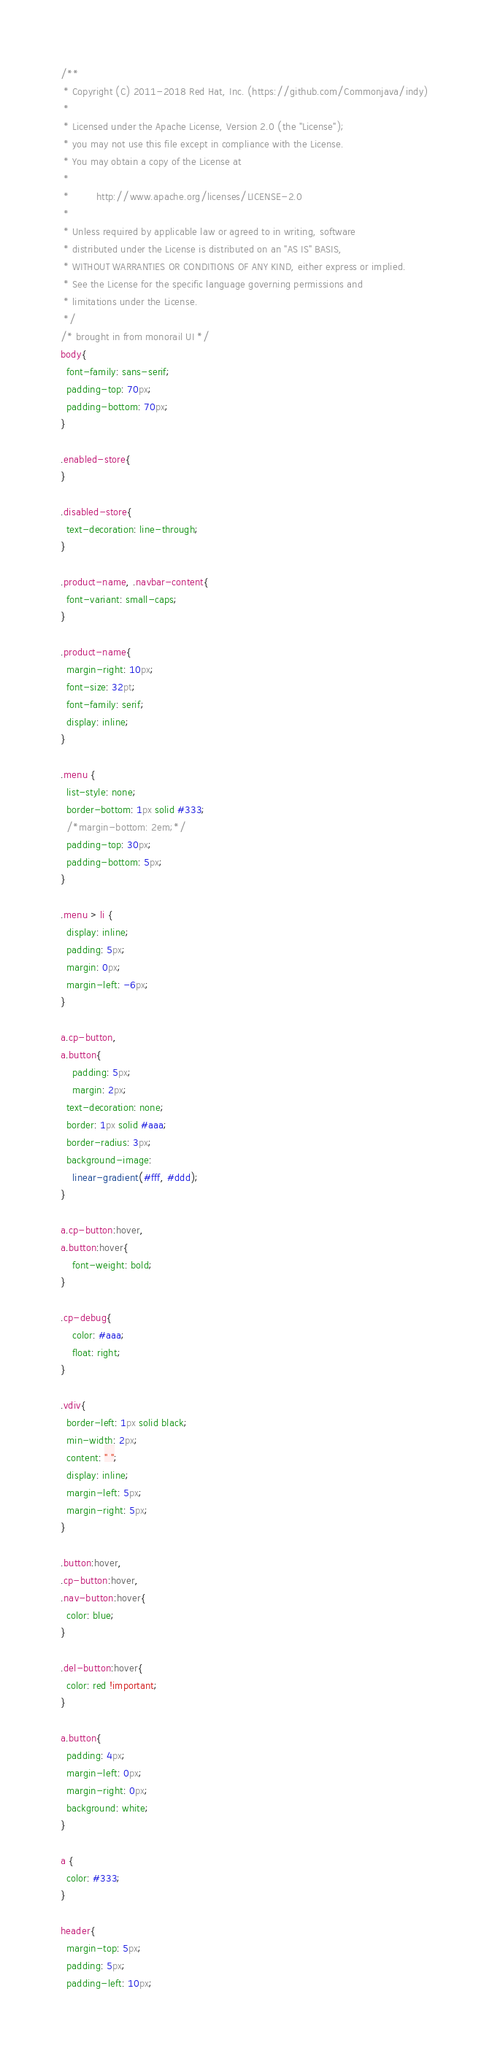<code> <loc_0><loc_0><loc_500><loc_500><_CSS_>/**
 * Copyright (C) 2011-2018 Red Hat, Inc. (https://github.com/Commonjava/indy)
 *
 * Licensed under the Apache License, Version 2.0 (the "License");
 * you may not use this file except in compliance with the License.
 * You may obtain a copy of the License at
 *
 *         http://www.apache.org/licenses/LICENSE-2.0
 *
 * Unless required by applicable law or agreed to in writing, software
 * distributed under the License is distributed on an "AS IS" BASIS,
 * WITHOUT WARRANTIES OR CONDITIONS OF ANY KIND, either express or implied.
 * See the License for the specific language governing permissions and
 * limitations under the License.
 */
/* brought in from monorail UI */
body{
  font-family: sans-serif;
  padding-top: 70px;
  padding-bottom: 70px;
}

.enabled-store{
}

.disabled-store{
  text-decoration: line-through;
}

.product-name, .navbar-content{
  font-variant: small-caps;
}

.product-name{
  margin-right: 10px;
  font-size: 32pt;
  font-family: serif;
  display: inline;
}

.menu {
  list-style: none;
  border-bottom: 1px solid #333;
  /*margin-bottom: 2em;*/
  padding-top: 30px;
  padding-bottom: 5px;
}

.menu > li {
  display: inline;
  padding: 5px;
  margin: 0px;
  margin-left: -6px;
}

a.cp-button,
a.button{
	padding: 5px;
	margin: 2px;
  text-decoration: none;
  border: 1px solid #aaa;
  border-radius: 3px;
  background-image:
    linear-gradient(#fff, #ddd);
}

a.cp-button:hover,
a.button:hover{
	font-weight: bold;
}

.cp-debug{
	color: #aaa;
	float: right;
}

.vdiv{
  border-left: 1px solid black;
  min-width: 2px;
  content: " ";
  display: inline;
  margin-left: 5px;
  margin-right: 5px;
}

.button:hover,
.cp-button:hover,
.nav-button:hover{
  color: blue;
}

.del-button:hover{
  color: red !important;
}

a.button{
  padding: 4px;
  margin-left: 0px;
  margin-right: 0px;
  background: white;
}

a {
  color: #333;
}

header{
  margin-top: 5px;
  padding: 5px;
  padding-left: 10px;</code> 